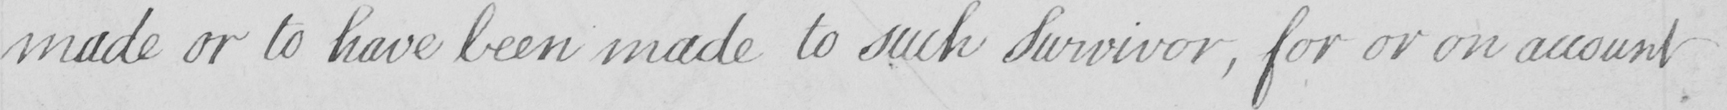What does this handwritten line say? made or to have been made to such Survivor , for or on account 